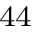<formula> <loc_0><loc_0><loc_500><loc_500>^ { 4 4 }</formula> 